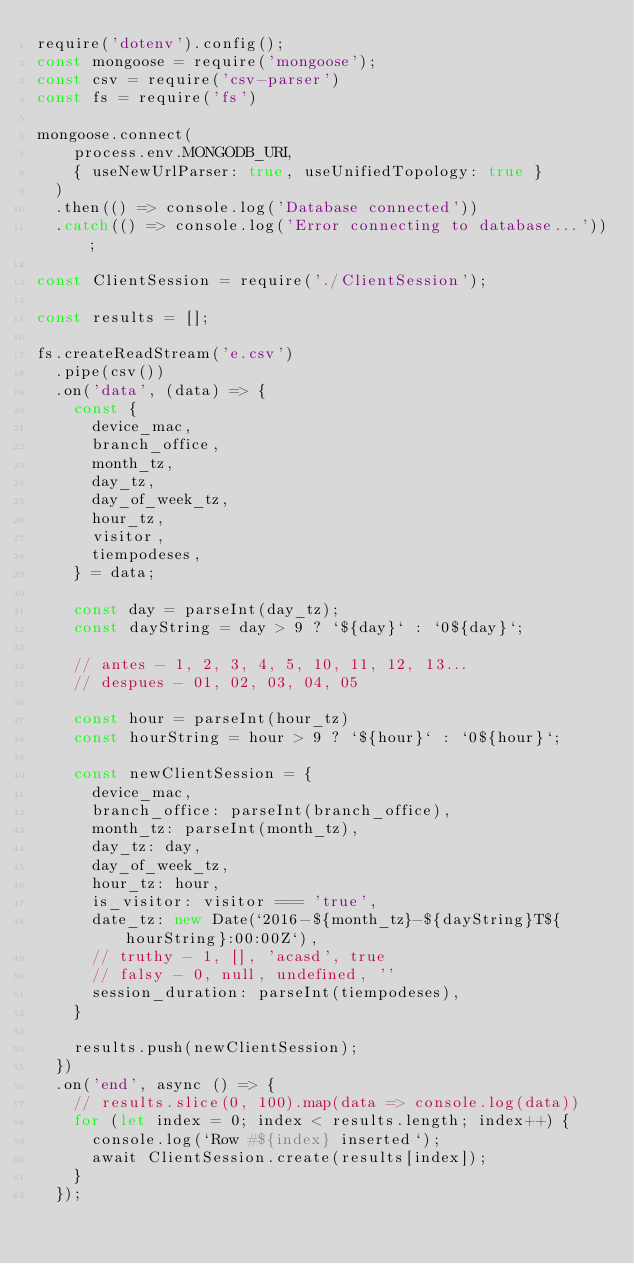<code> <loc_0><loc_0><loc_500><loc_500><_JavaScript_>require('dotenv').config();
const mongoose = require('mongoose');
const csv = require('csv-parser')
const fs = require('fs')

mongoose.connect(
    process.env.MONGODB_URI,
    { useNewUrlParser: true, useUnifiedTopology: true }
  )
  .then(() => console.log('Database connected'))
  .catch(() => console.log('Error connecting to database...'));

const ClientSession = require('./ClientSession');

const results = [];  

fs.createReadStream('e.csv')
  .pipe(csv())
  .on('data', (data) => {
    const {
      device_mac,
      branch_office,
      month_tz,
      day_tz,
      day_of_week_tz,
      hour_tz,
      visitor,
      tiempodeses,
    } = data;

    const day = parseInt(day_tz);
    const dayString = day > 9 ? `${day}` : `0${day}`;

    // antes - 1, 2, 3, 4, 5, 10, 11, 12, 13...
    // despues - 01, 02, 03, 04, 05
        
    const hour = parseInt(hour_tz)
    const hourString = hour > 9 ? `${hour}` : `0${hour}`;

    const newClientSession = {
      device_mac,
      branch_office: parseInt(branch_office),
      month_tz: parseInt(month_tz),
      day_tz: day,
      day_of_week_tz,
      hour_tz: hour,
      is_visitor: visitor === 'true',
      date_tz: new Date(`2016-${month_tz}-${dayString}T${hourString}:00:00Z`),
      // truthy - 1, [], 'acasd', true
      // falsy - 0, null, undefined, ''
      session_duration: parseInt(tiempodeses),
    }

    results.push(newClientSession);
  })
  .on('end', async () => {
    // results.slice(0, 100).map(data => console.log(data))
    for (let index = 0; index < results.length; index++) {
      console.log(`Row #${index} inserted`);
      await ClientSession.create(results[index]);
    }
  });
  
</code> 